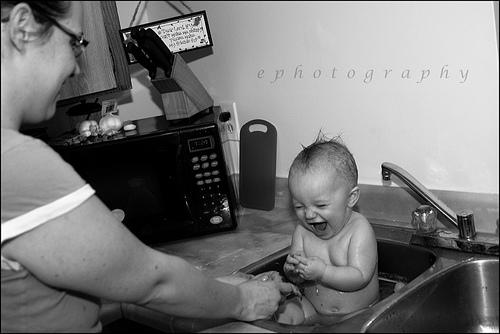What color is the photo?
Give a very brief answer. Black and white. Is the water cold?
Quick response, please. No. What room are they in?
Be succinct. Kitchen. How is the woman holding her youngest child?
Short answer required. In sink. Does this picture make sense?
Concise answer only. Yes. What is in the child's mouth?
Answer briefly. Nothing. Is this baby happy to be taking a bath?
Concise answer only. Yes. 